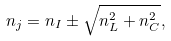Convert formula to latex. <formula><loc_0><loc_0><loc_500><loc_500>n _ { j } = n _ { I } \pm \sqrt { n _ { L } ^ { 2 } + n _ { C } ^ { 2 } } ,</formula> 